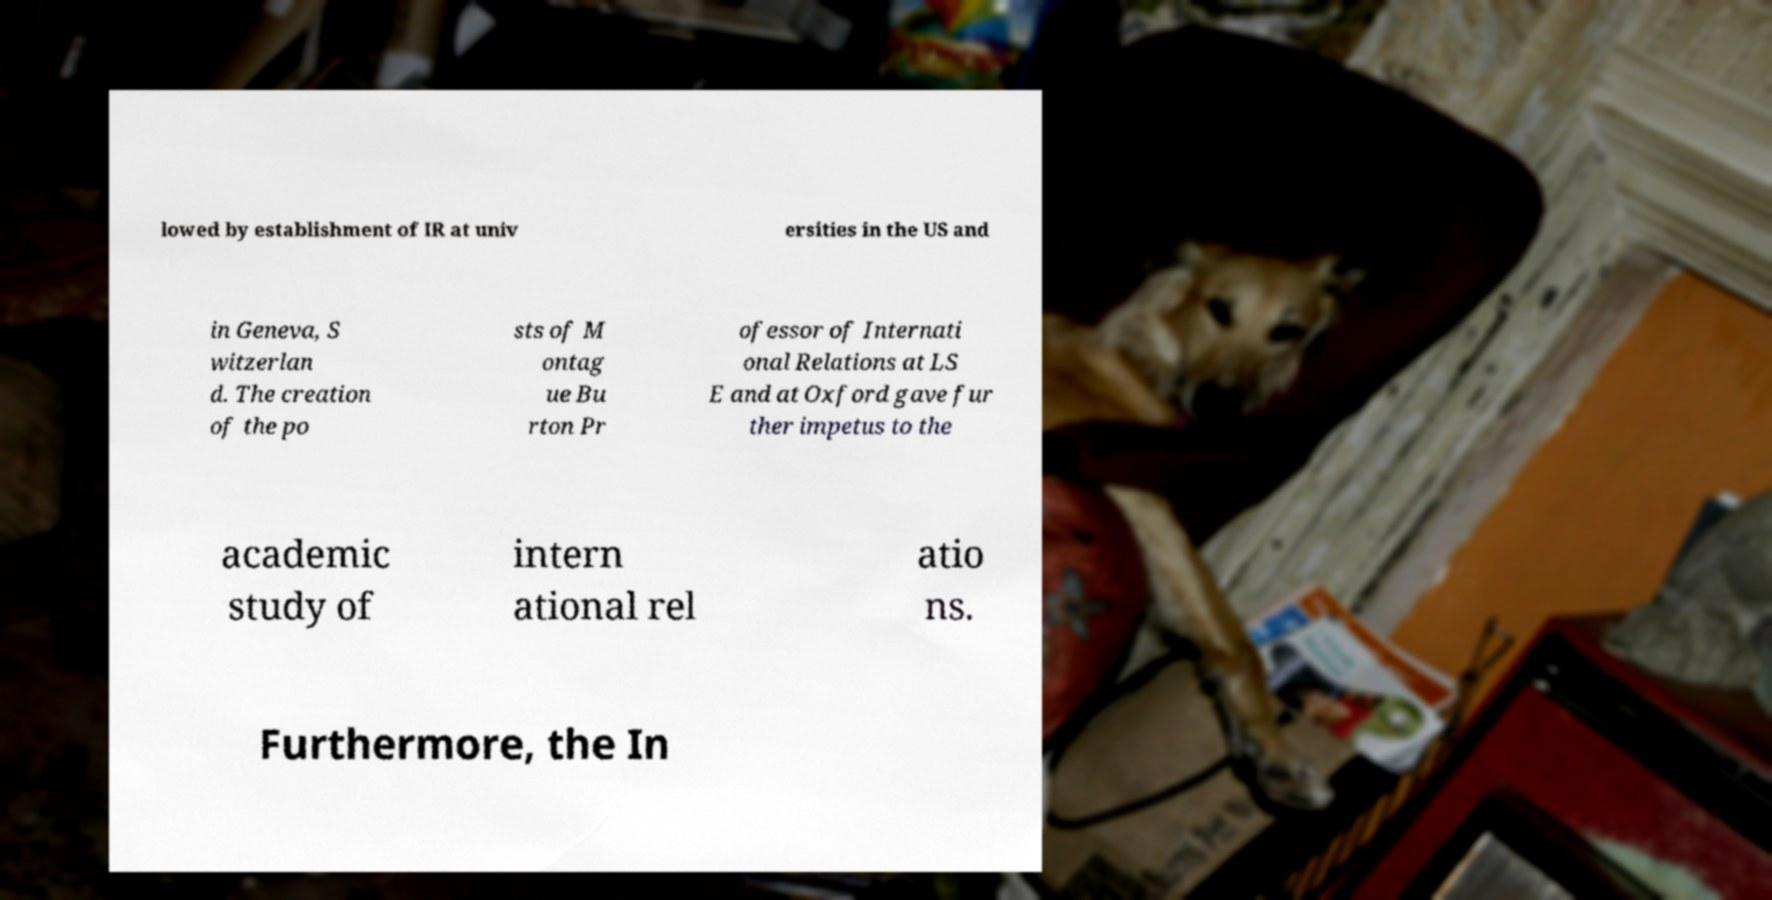Can you accurately transcribe the text from the provided image for me? lowed by establishment of IR at univ ersities in the US and in Geneva, S witzerlan d. The creation of the po sts of M ontag ue Bu rton Pr ofessor of Internati onal Relations at LS E and at Oxford gave fur ther impetus to the academic study of intern ational rel atio ns. Furthermore, the In 